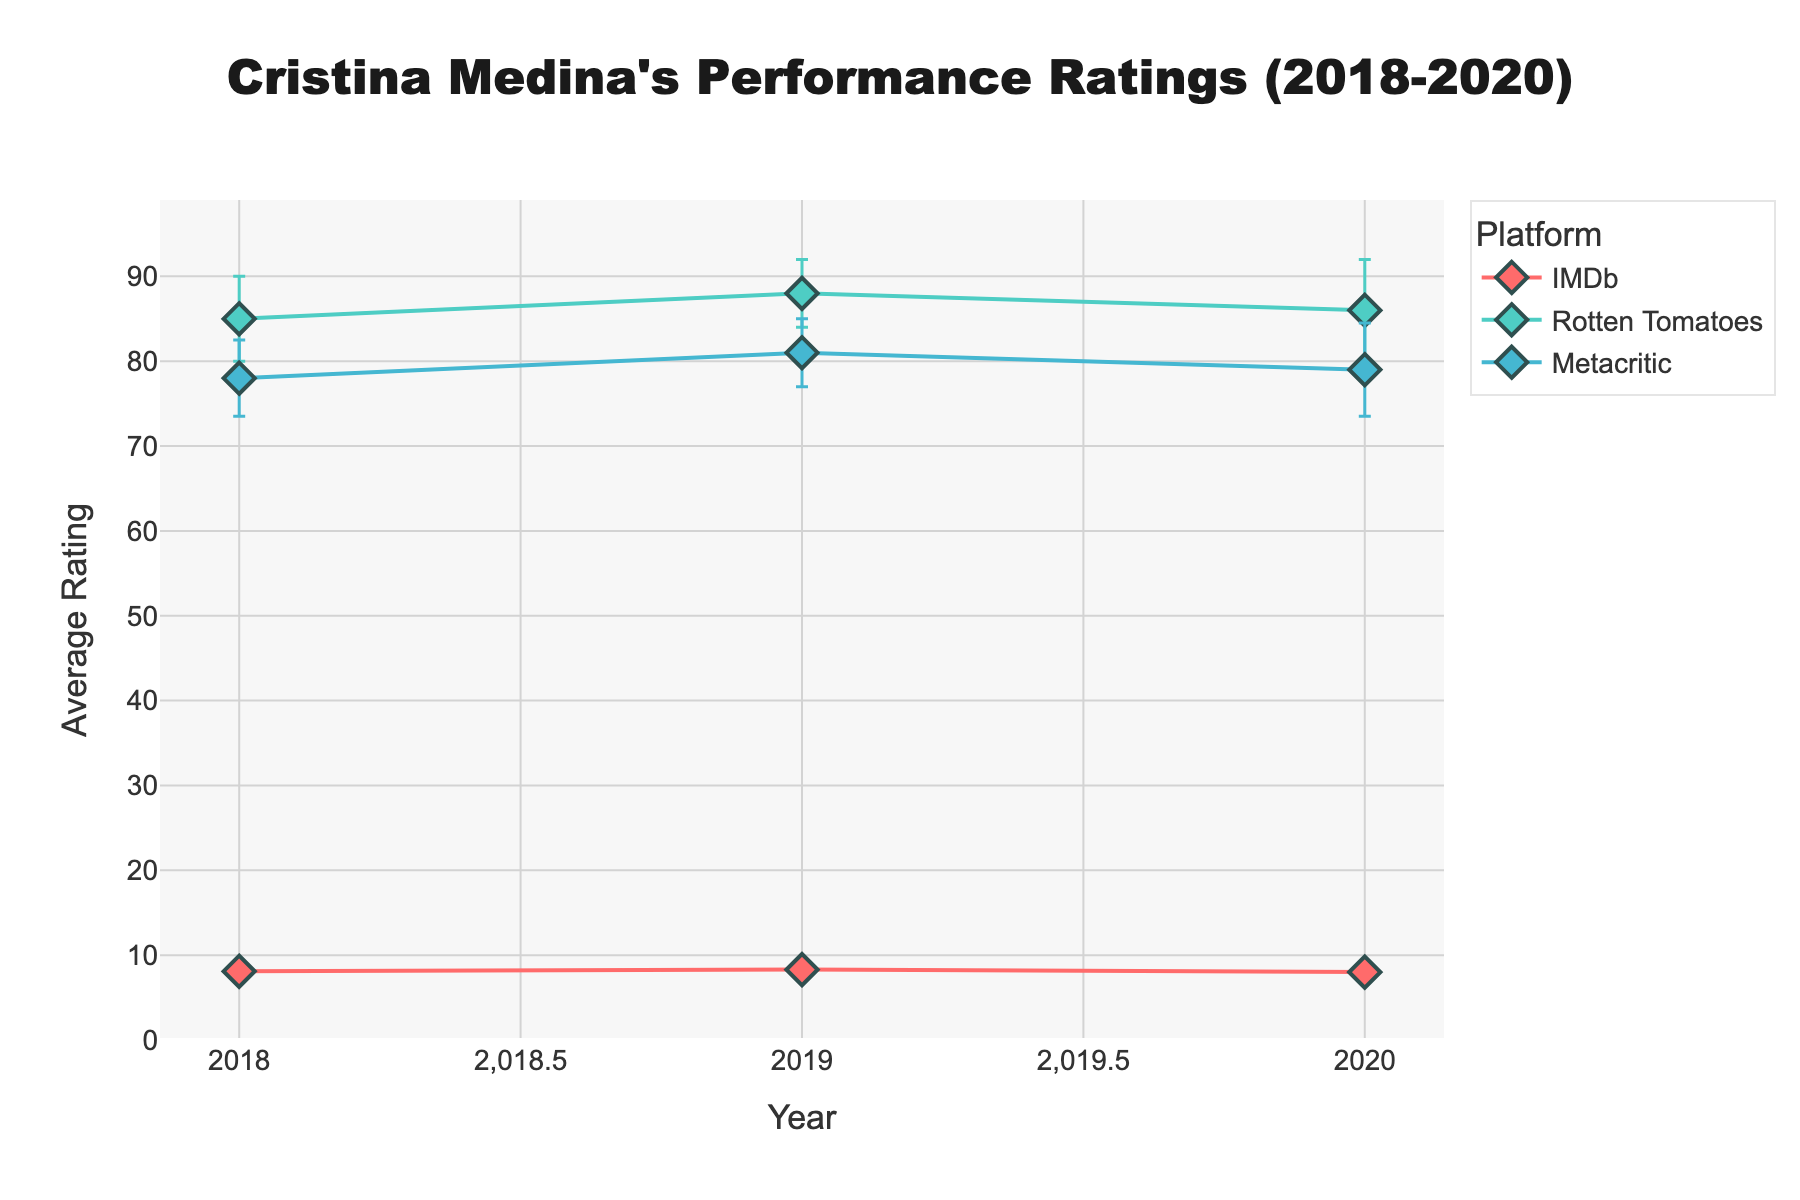What's the average rating for Cristina Medina on Rotten Tomatoes in 2019? The chart shows a data point for Rotten Tomatoes in 2019 with an average rating. Look for the dot corresponding to 2019 in the Rotten Tomatoes line and note the value.
Answer: 88 How did Cristina Medina's IMDb ratings change from 2019 to 2020? Identify the data points for IMDb in 2019 and 2020. Compare the values to see if they increased, decreased, or stayed the same.
Answer: Decreased Which platform had the highest average rating in 2018? Locate the data points for 2018 across all platforms. Compare the average ratings to determine which one is the highest.
Answer: IMDb What is the range of the average ratings for Metacritic from 2018 to 2020? Identify the highest and lowest average ratings for Metacritic across 2018, 2019, and 2020. Subtract the lowest from the highest to find the range.
Answer: 3 Which year had the smallest rating standard deviation for Rotten Tomatoes? Look at the error bars for Rotten Tomatoes across 2018, 2019, and 2020. The year with the shortest error bar has the smallest standard deviation.
Answer: 2019 Compare the rating trends for IMDb and Rotten Tomatoes over the years. Which platform shows more variability in ratings? Observe the error bars for both IMDb and Rotten Tomatoes from 2018 to 2020. Determine which platform's error bars are generally longer, indicating more variability.
Answer: IMDb What's the average rating for Metacritic in 2019? The chart shows a data point for Metacritic in 2019 with an average rating. Look for the dot corresponding to 2019 in the Metacritic line and note the value.
Answer: 81 Which platform showed the most consistent ratings for Cristina Medina over the years? Consistency can be observed by looking at the error bars' lengths. The platform with the shortest average error bars over the years shows the most consistency.
Answer: Rotten Tomatoes 